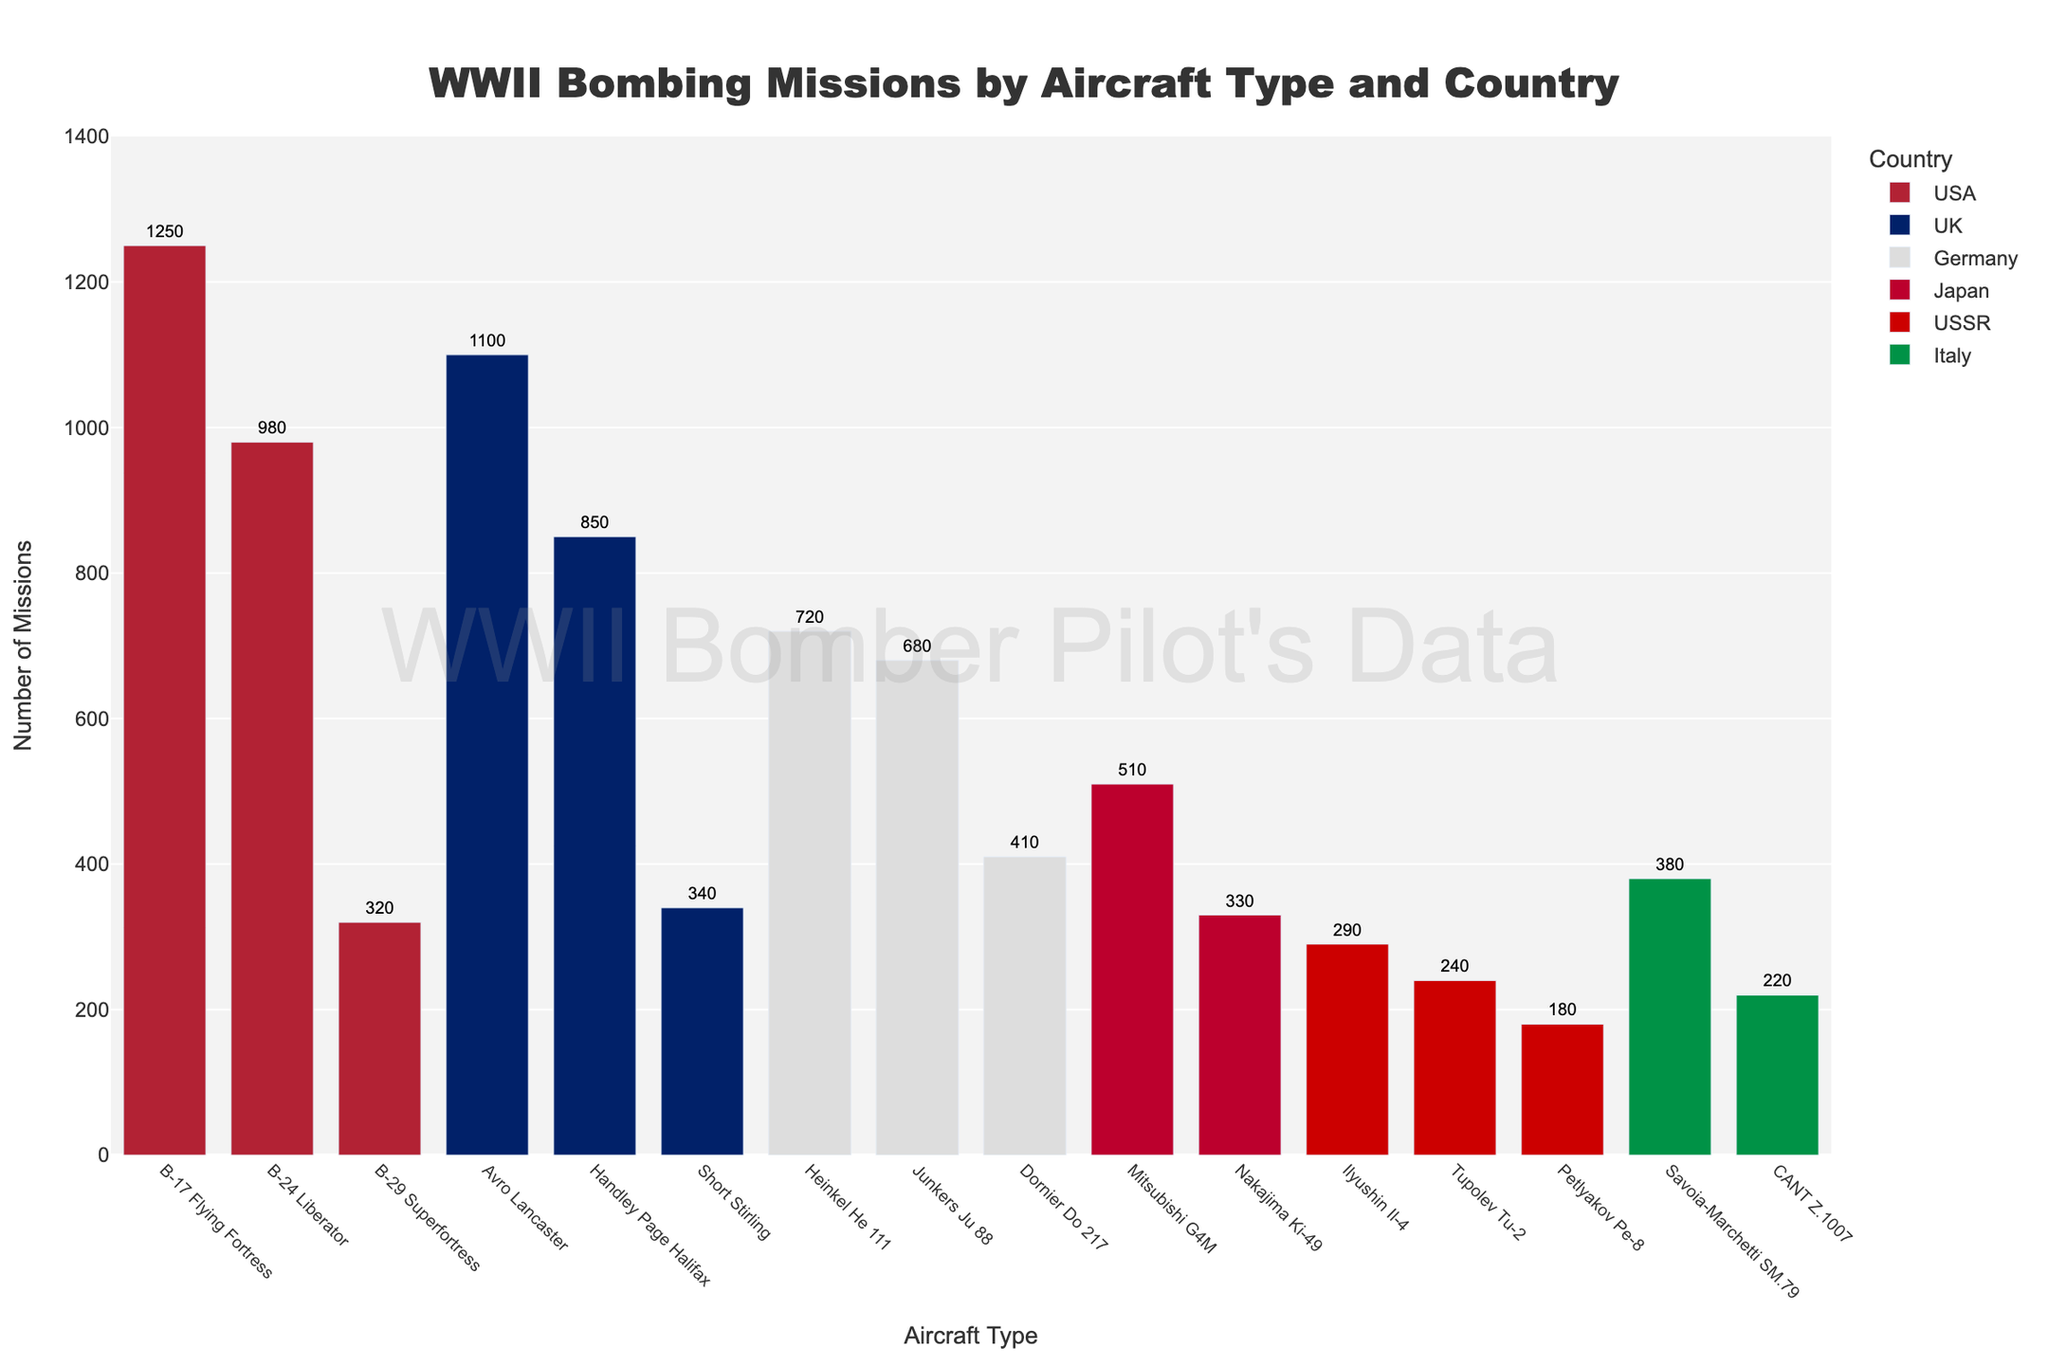Which country has the most aircraft types listed in the figure? By observing the figure, count the different aircraft types listed under each country. The UK has the highest count with three different aircraft types (Avro Lancaster, Handley Page Halifax, Short Stirling).
Answer: UK How many more missions did the USA's B-17 Flying Fortress have compared to the USSR's Petlyakov Pe-8? Note the total missions for the B-17 Flying Fortress (1250) and Petlyakov Pe-8 (180). Subtract the missions of the Petlyakov Pe-8 from the B-17 Flying Fortress (1250 - 180 = 1070).
Answer: 1070 Which country flew the second-highest number of bombing missions? From the groupings in the figure, observe that the USA has the highest aggregate, followed by the UK.
Answer: UK What is the range in the number of missions for the German aircraft? Identify the missions for German aircraft (Heinkel He 111: 720, Junkers Ju 88: 680, Dornier Do 217: 410). Calculate the range by subtracting the lowest value from the highest (720 - 410 = 310).
Answer: 310 Which aircraft type had the fewest missions, and from which country does it originate? Look for the aircraft type with the smallest number of missions in the figure, which is the USSR's Petlyakov Pe-8 with 180 missions.
Answer: Petlyakov Pe-8, USSR Which two aircraft types from Japan, combined, have more missions than the Italian Savoia-Marchetti SM.79? Compare the missions of Japanese aircraft (Mitsubishi G4M: 510, Nakajima Ki-49: 330) to the Italian Savoia-Marchetti SM.79 (380). Adding the two Japanese aircraft (510 + 330 = 840), which exceeds 380.
Answer: Mitsubishi G4M and Nakajima Ki-49 Between the USA's B-24 Liberator and the UK's Avro Lancaster, which has more missions, and by how many? Compare the B-24 Liberator (980 missions) with the Avro Lancaster (1100 missions). Calculate the difference (1100 - 980 = 120).
Answer: Avro Lancaster, 120 What color represents Germany's aircraft in the figure? Observe the color used in the figure's legend for Germany. The aircraft for Germany are represented in grey.
Answer: Grey How many fewer missions did Germany's Dornier Do 217 have compared to the UK's Handley Page Halifax? Note the missions for Dornier Do 217 (410) and Handley Page Halifax (850). Subtract the Dornier Do 217 missions from Handley Page Halifax (850 - 410 = 440).
Answer: 440 What is the combined total number of missions flown by all Italian aircraft types? Sum up the missions for the Italian aircraft: Savoia-Marchetti SM.79 (380) and CANT Z.1007 (220). Adding them together gives (380 + 220 = 600).
Answer: 600 